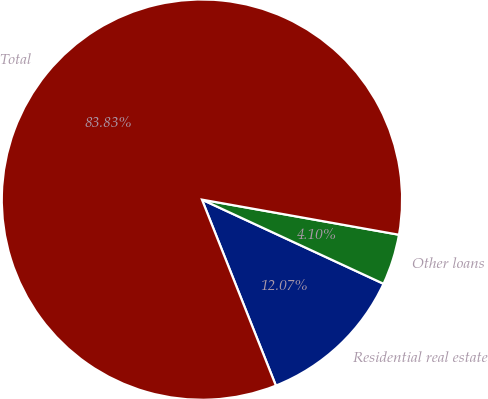Convert chart to OTSL. <chart><loc_0><loc_0><loc_500><loc_500><pie_chart><fcel>Residential real estate<fcel>Other loans<fcel>Total<nl><fcel>12.07%<fcel>4.1%<fcel>83.83%<nl></chart> 